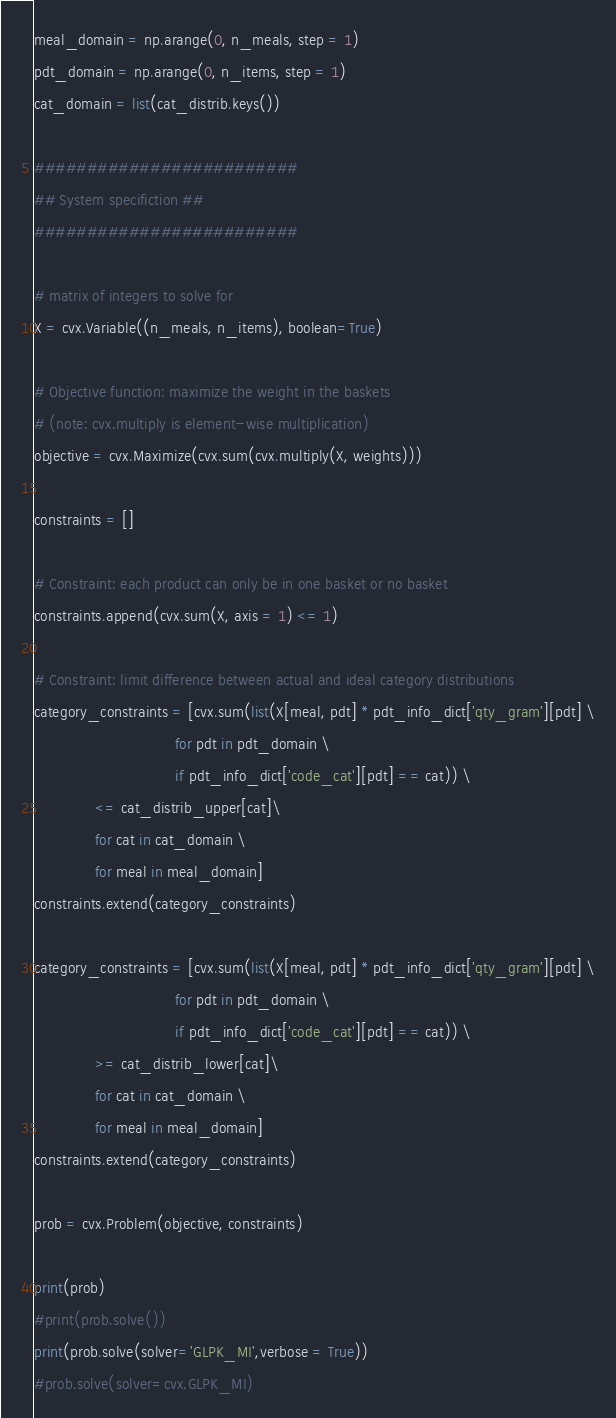Convert code to text. <code><loc_0><loc_0><loc_500><loc_500><_Python_>meal_domain = np.arange(0, n_meals, step = 1)
pdt_domain = np.arange(0, n_items, step = 1)
cat_domain = list(cat_distrib.keys())

#########################
## System specifiction ##
#########################

# matrix of integers to solve for
X = cvx.Variable((n_meals, n_items), boolean=True)

# Objective function: maximize the weight in the baskets
# (note: cvx.multiply is element-wise multiplication)
objective = cvx.Maximize(cvx.sum(cvx.multiply(X, weights)))

constraints = []

# Constraint: each product can only be in one basket or no basket
constraints.append(cvx.sum(X, axis = 1) <= 1)

# Constraint: limit difference between actual and ideal category distributions
category_constraints = [cvx.sum(list(X[meal, pdt] * pdt_info_dict['qty_gram'][pdt] \
                                for pdt in pdt_domain \
                                if pdt_info_dict['code_cat'][pdt] == cat)) \
              <= cat_distrib_upper[cat]\
              for cat in cat_domain \
              for meal in meal_domain]
constraints.extend(category_constraints)

category_constraints = [cvx.sum(list(X[meal, pdt] * pdt_info_dict['qty_gram'][pdt] \
                                for pdt in pdt_domain \
                                if pdt_info_dict['code_cat'][pdt] == cat)) \
              >= cat_distrib_lower[cat]\
              for cat in cat_domain \
              for meal in meal_domain]
constraints.extend(category_constraints)

prob = cvx.Problem(objective, constraints)

print(prob)
#print(prob.solve())
print(prob.solve(solver='GLPK_MI',verbose = True))
#prob.solve(solver=cvx.GLPK_MI)

</code> 